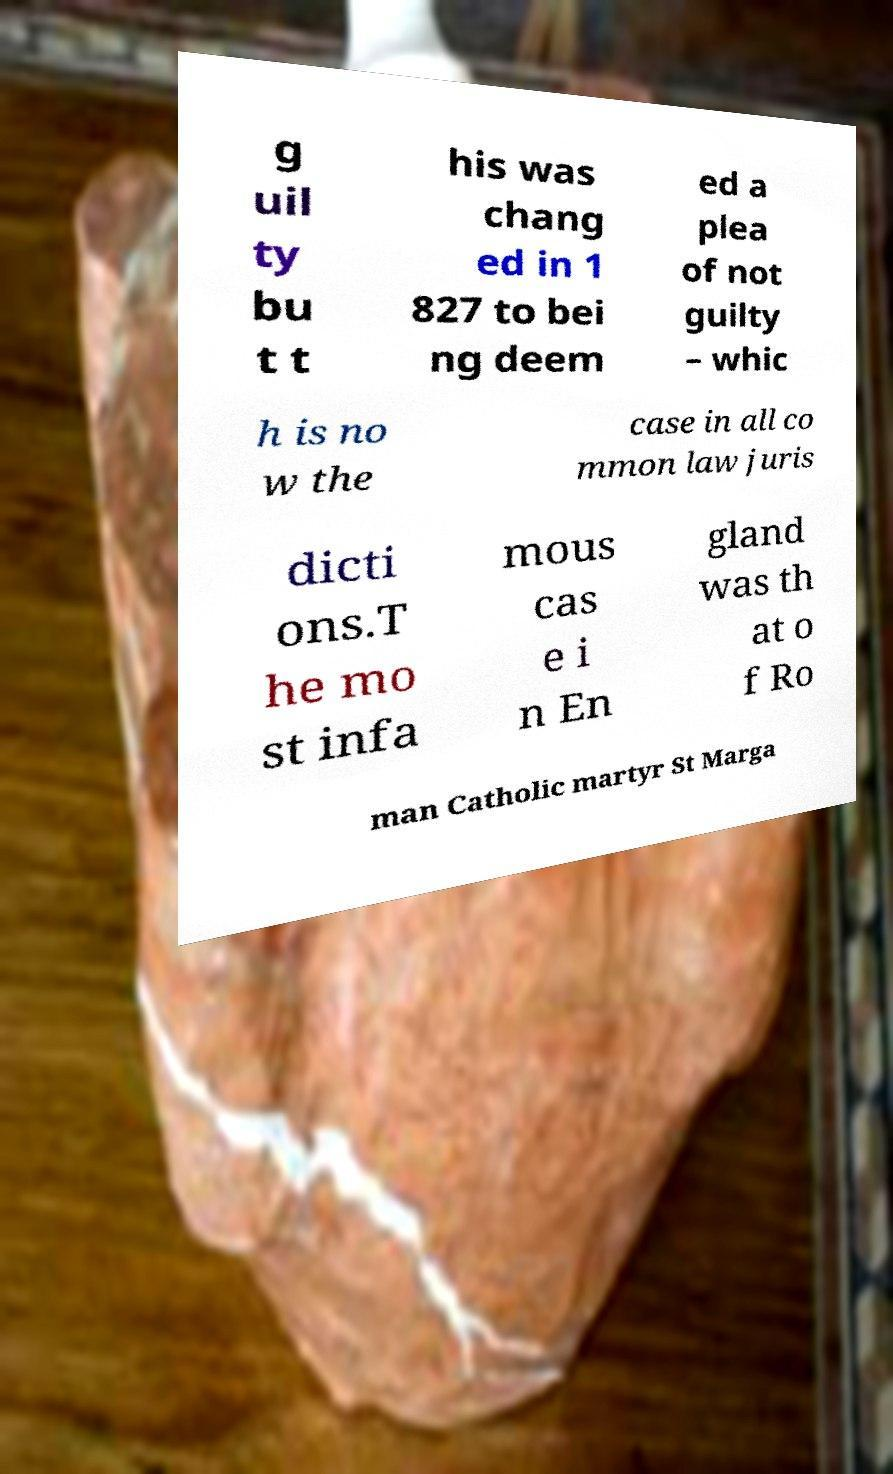There's text embedded in this image that I need extracted. Can you transcribe it verbatim? g uil ty bu t t his was chang ed in 1 827 to bei ng deem ed a plea of not guilty – whic h is no w the case in all co mmon law juris dicti ons.T he mo st infa mous cas e i n En gland was th at o f Ro man Catholic martyr St Marga 